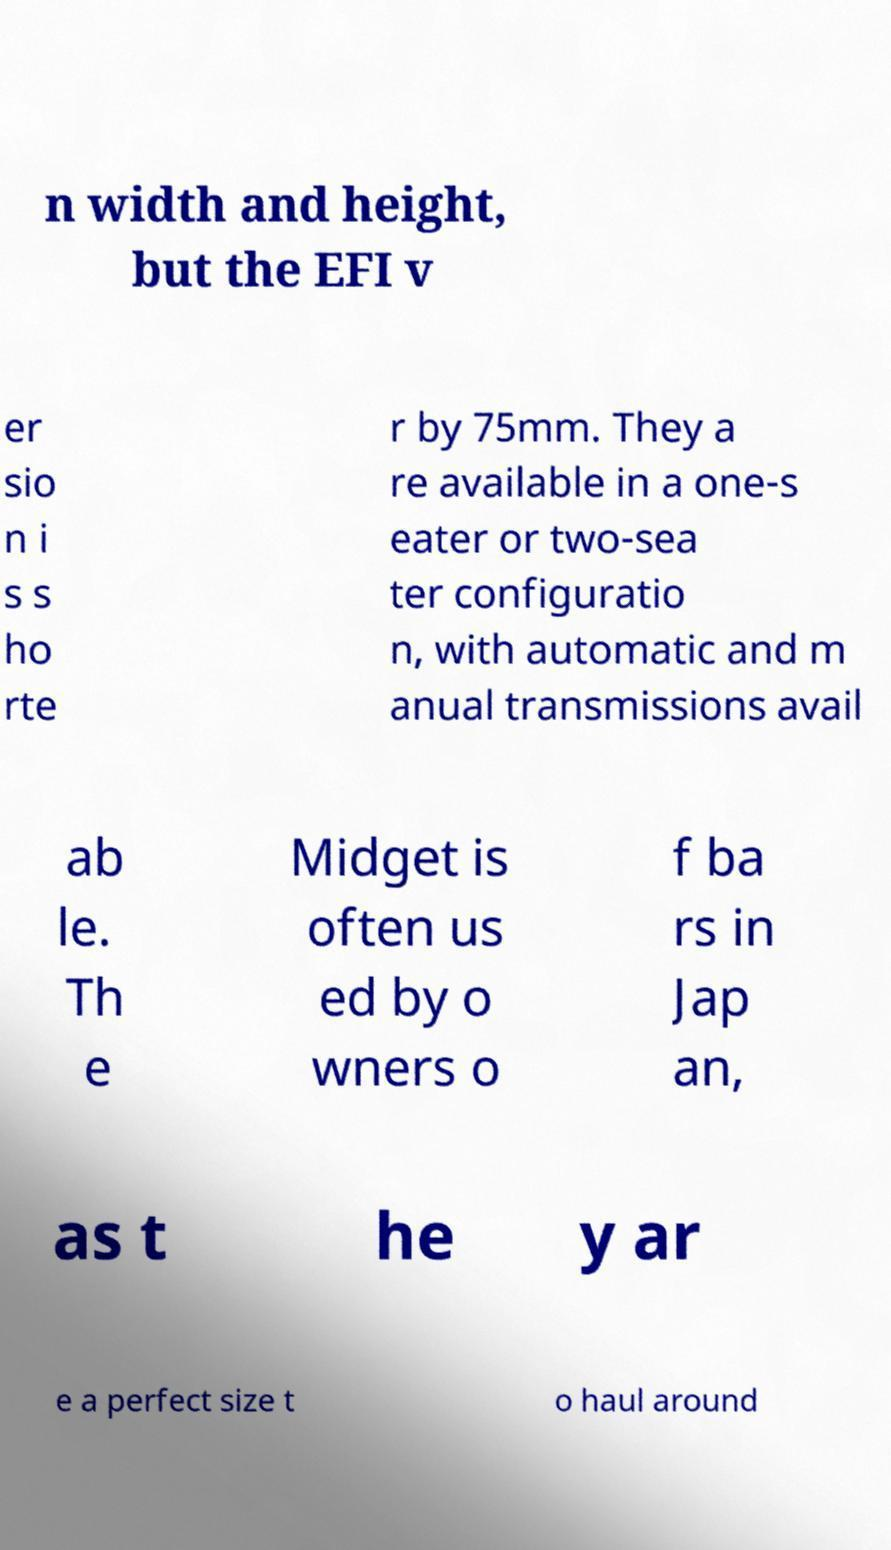Could you extract and type out the text from this image? n width and height, but the EFI v er sio n i s s ho rte r by 75mm. They a re available in a one-s eater or two-sea ter configuratio n, with automatic and m anual transmissions avail ab le. Th e Midget is often us ed by o wners o f ba rs in Jap an, as t he y ar e a perfect size t o haul around 